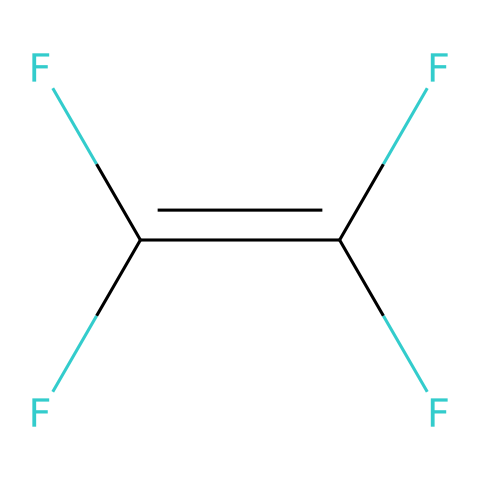What is the molecular formula of tetrafluoroethylene? The molecular formula can be derived from the number and type of atoms present. The SMILES structure shows four fluorine (F) atoms and two carbon (C) atoms, making the formula C2F4.
Answer: C2F4 How many double bonds are present in tetrafluoroethylene? By analyzing the SMILES structure, we can see that the "C=C" notation indicates one double bond between the carbon atoms. Thus, there is one double bond in the structure.
Answer: 1 What type of bonding is indicated by the presence of carbon-carbon double bonds in the structure? The carbon-carbon double bond (C=C) presented in the structure signifies the presence of covalent bonding, which is a type of chemical bond where electrons are shared between atoms.
Answer: covalent How many fluorine atoms are bonded to each carbon atom? Evaluating the structural representation indicates that each carbon atom is bonded to two fluorine (F) atoms, as each carbon is attached to two F groups in the SMILES notation.
Answer: 2 What is the significance of tetrafluoroethylene in SpaceX's materials? Tetrafluoroethylene is critical for producing materials that require high thermal stability and resistance to heat, essential for applications in aerospace and rocket technologies, such as insulation and seals.
Answer: thermal stability What type of polymer can be created from tetrafluoroethylene? Tetrafluoroethylene is used to produce polytetrafluoroethylene (PTFE), a well-known polymer with high chemical resistance and low friction properties, commonly recognized as Teflon.
Answer: PTFE 